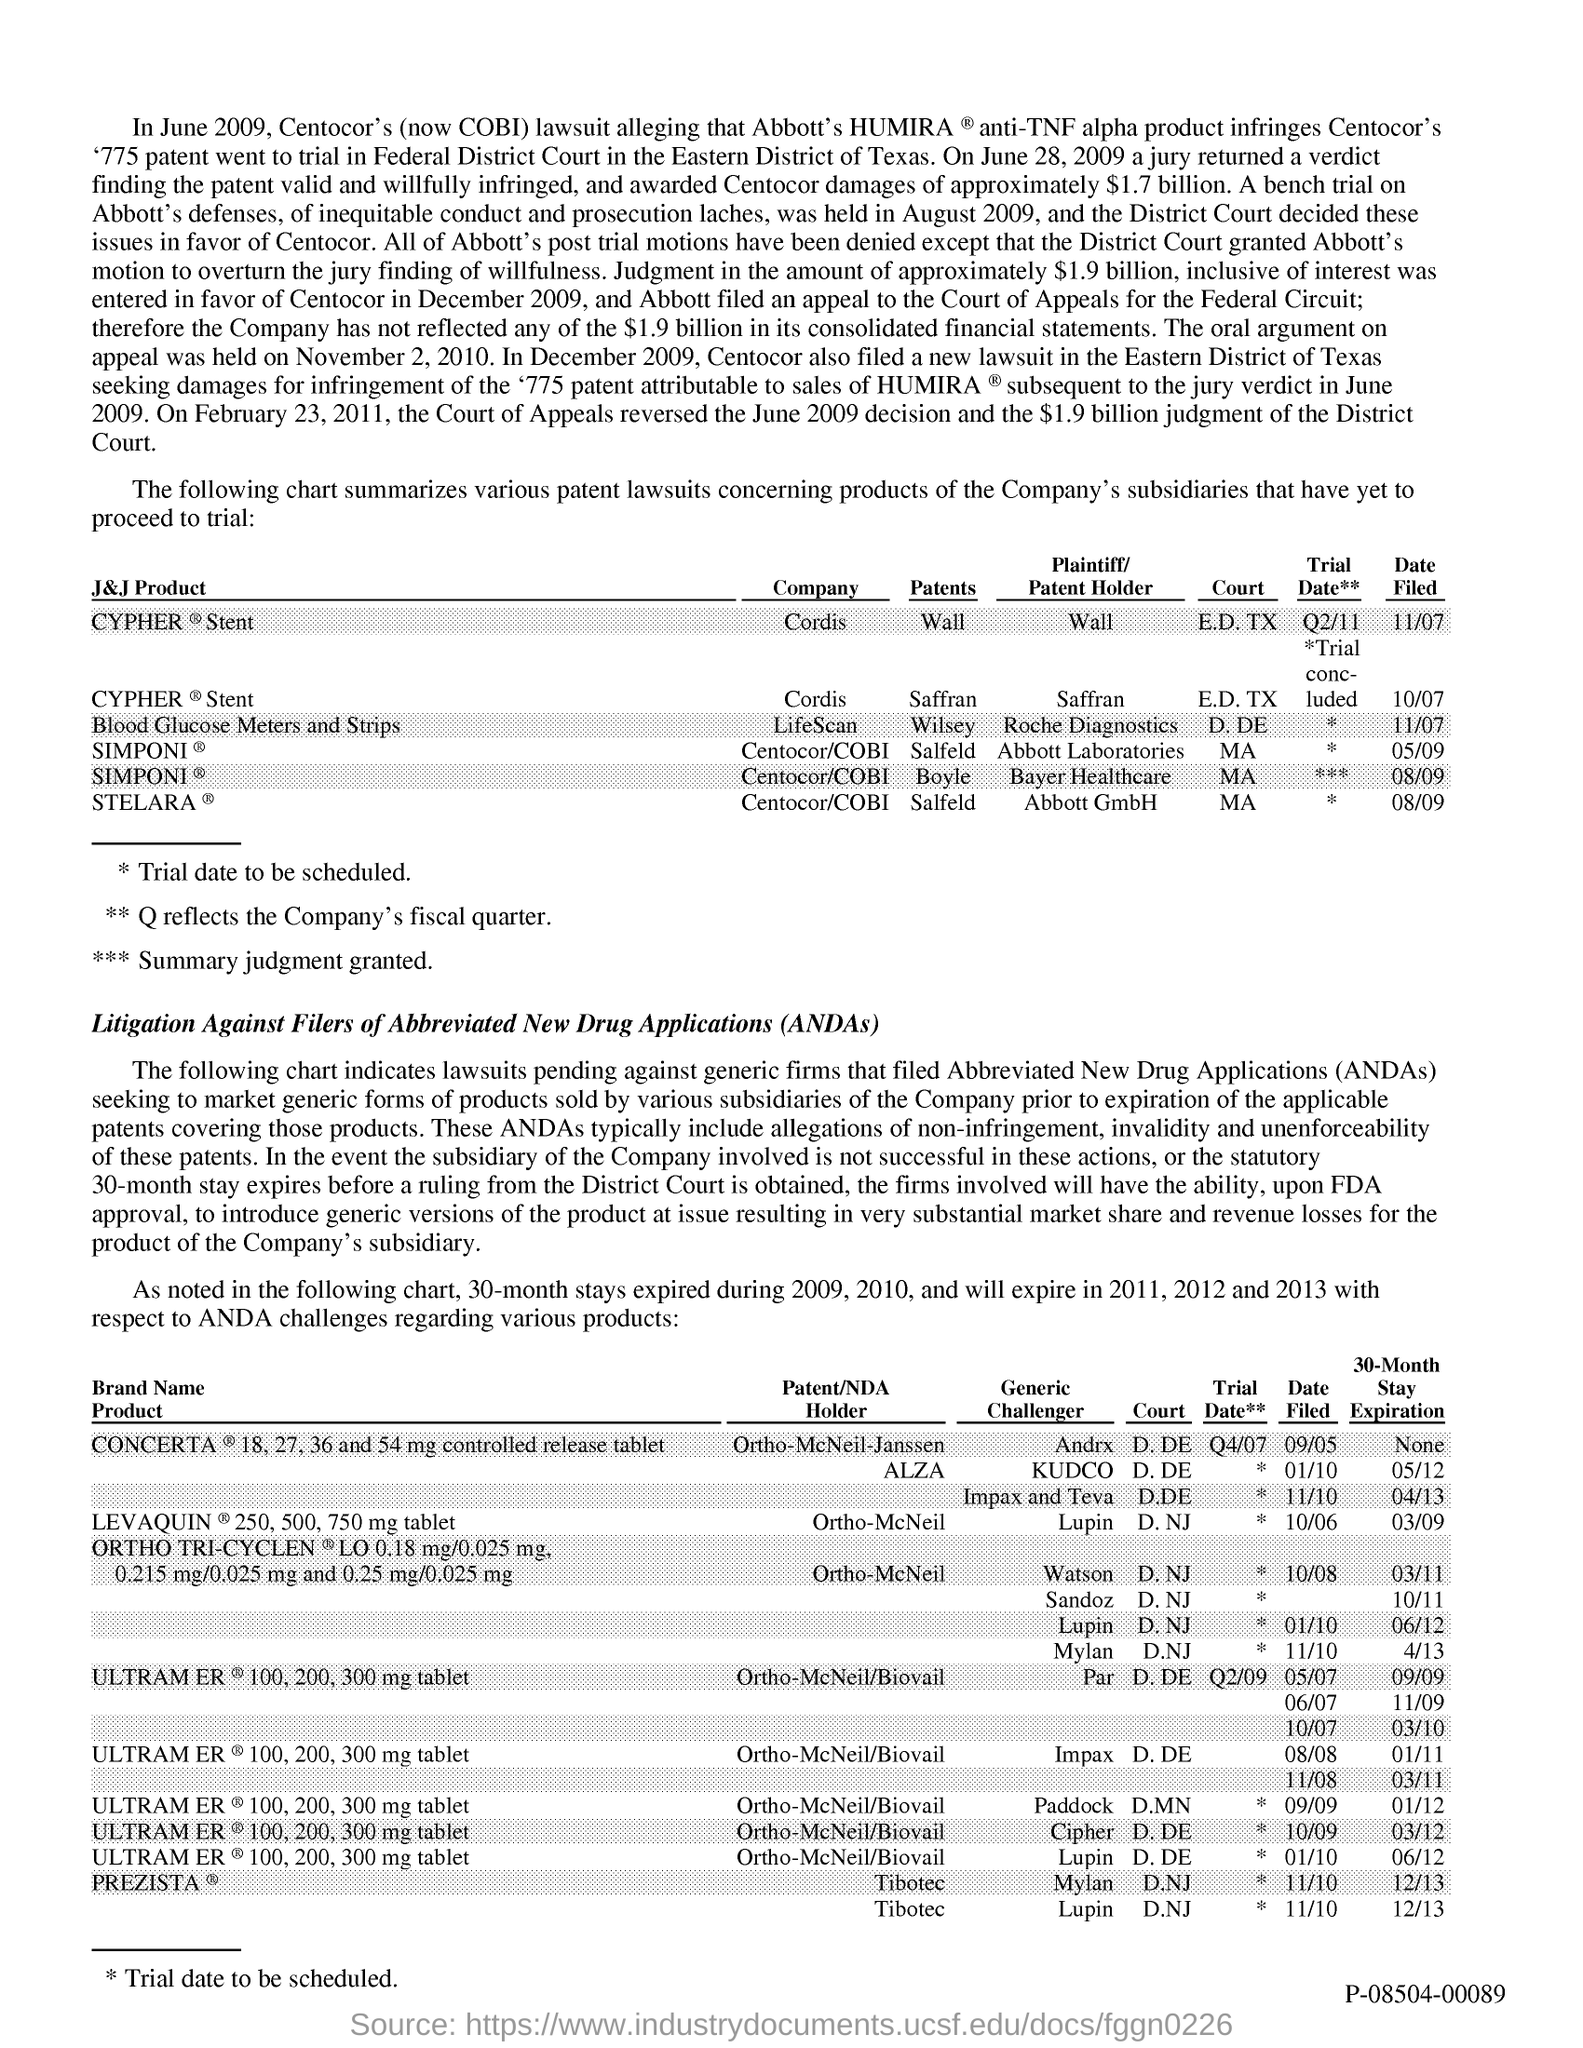Highlight a few significant elements in this photo. ANDAs refer to Abbreviated New Drug Applications, which are a type of application submitted to the U.S. Food and Drug Administration (FDA) for the approval of a generic drug product. 